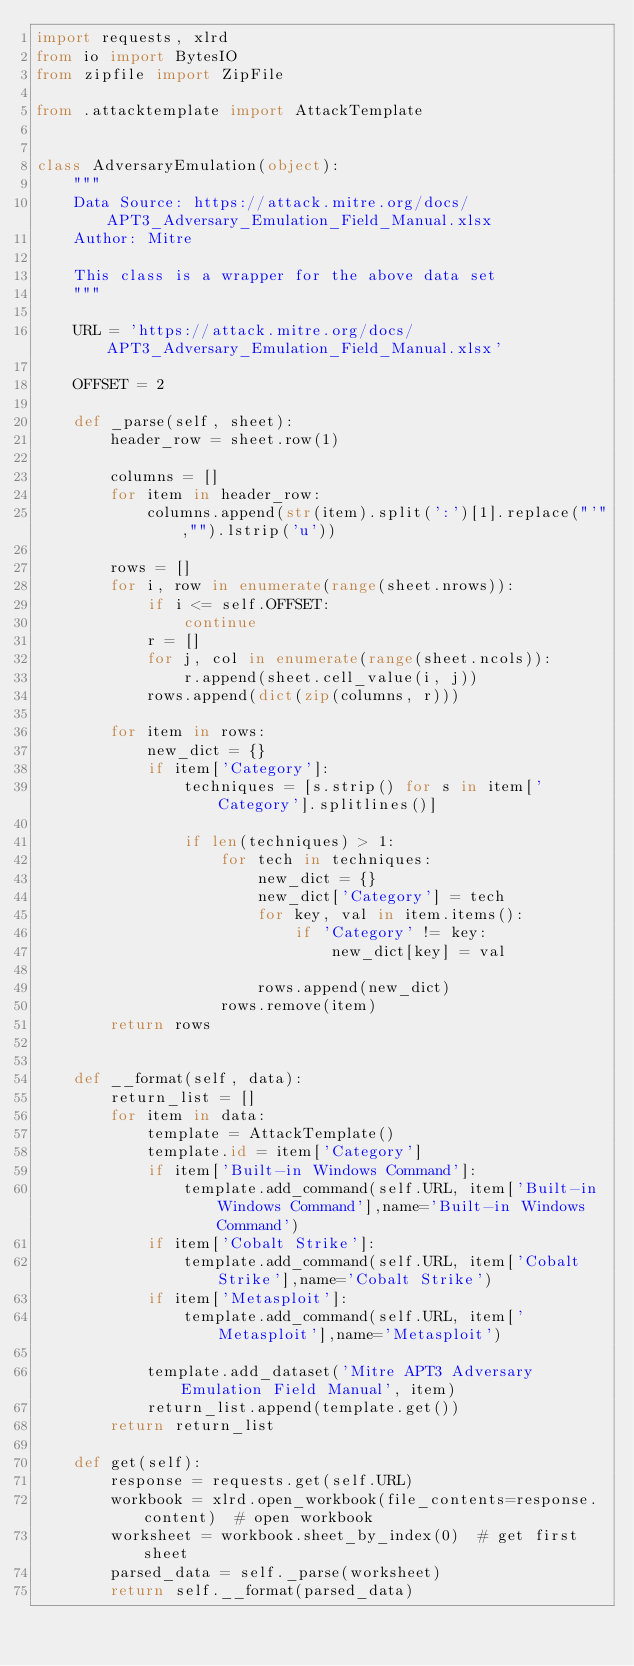<code> <loc_0><loc_0><loc_500><loc_500><_Python_>import requests, xlrd
from io import BytesIO
from zipfile import ZipFile

from .attacktemplate import AttackTemplate


class AdversaryEmulation(object):
    """
    Data Source: https://attack.mitre.org/docs/APT3_Adversary_Emulation_Field_Manual.xlsx
    Author: Mitre

    This class is a wrapper for the above data set
    """

    URL = 'https://attack.mitre.org/docs/APT3_Adversary_Emulation_Field_Manual.xlsx'

    OFFSET = 2
    
    def _parse(self, sheet):
        header_row = sheet.row(1)

        columns = []
        for item in header_row:
            columns.append(str(item).split(':')[1].replace("'","").lstrip('u'))
    
        rows = []
        for i, row in enumerate(range(sheet.nrows)):
            if i <= self.OFFSET:
                continue
            r = []
            for j, col in enumerate(range(sheet.ncols)):
                r.append(sheet.cell_value(i, j))
            rows.append(dict(zip(columns, r)))

        for item in rows:
            new_dict = {}
            if item['Category']:
                techniques = [s.strip() for s in item['Category'].splitlines()]

                if len(techniques) > 1:
                    for tech in techniques:
                        new_dict = {}
                        new_dict['Category'] = tech
                        for key, val in item.items():
                            if 'Category' != key:
                                new_dict[key] = val
                        
                        rows.append(new_dict)
                    rows.remove(item)
        return rows


    def __format(self, data):
        return_list = []
        for item in data:
            template = AttackTemplate()
            template.id = item['Category']
            if item['Built-in Windows Command']:
                template.add_command(self.URL, item['Built-in Windows Command'],name='Built-in Windows Command')
            if item['Cobalt Strike']:
                template.add_command(self.URL, item['Cobalt Strike'],name='Cobalt Strike')
            if item['Metasploit']:
                template.add_command(self.URL, item['Metasploit'],name='Metasploit')
                
            template.add_dataset('Mitre APT3 Adversary Emulation Field Manual', item)
            return_list.append(template.get())
        return return_list

    def get(self):
        response = requests.get(self.URL)
        workbook = xlrd.open_workbook(file_contents=response.content)  # open workbook
        worksheet = workbook.sheet_by_index(0)  # get first sheet
        parsed_data = self._parse(worksheet)
        return self.__format(parsed_data)</code> 